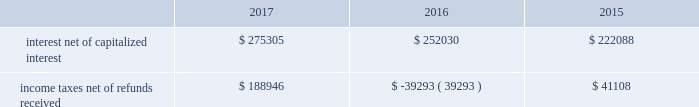The diluted earnings per share calculation excludes stock options , sars , restricted stock and units and performance units and stock that were anti-dilutive .
Shares underlying the excluded stock options and sars totaled 2.6 million , 10.3 million and 10.2 million for the years ended december 31 , 2017 , 2016 and 2015 , respectively .
For the year ended december 31 , 2016 , 4.5 million shares of restricted stock and restricted stock units and performance units and performance stock were excluded .
10 .
Supplemental cash flow information net cash paid for interest and income taxes was as follows for the years ended december 31 , 2017 , 2016 and 2015 ( in thousands ) : .
Eog's accrued capital expenditures at december 31 , 2017 , 2016 and 2015 were $ 475 million , $ 388 million and $ 416 million , respectively .
Non-cash investing activities for the year ended december 31 , 2017 included non-cash additions of $ 282 million to eog's oil and gas properties as a result of property exchanges .
Non-cash investing activities for the year ended december 31 , 2016 included $ 3834 million in non-cash additions to eog's oil and gas properties related to the yates transaction ( see note 17 ) .
11 .
Business segment information eog's operations are all crude oil and natural gas exploration and production related .
The segment reporting topic of the asc establishes standards for reporting information about operating segments in annual financial statements .
Operating segments are defined as components of an enterprise about which separate financial information is available and evaluated regularly by the chief operating decision maker , or decision-making group , in deciding how to allocate resources and in assessing performance .
Eog's chief operating decision-making process is informal and involves the chairman of the board and chief executive officer and other key officers .
This group routinely reviews and makes operating decisions related to significant issues associated with each of eog's major producing areas in the united states , trinidad , the united kingdom and china .
For segment reporting purposes , the chief operating decision maker considers the major united states producing areas to be one operating segment. .
What is the increase observed in accrued capital expenditures during 2016 and 2017? 
Rationale: it is the value of accrued capital expenditures in 2017 divided by the 2016's , then turned into a percentage to represent the increase .
Computations: ((475 / 388) - 1)
Answer: 0.22423. 